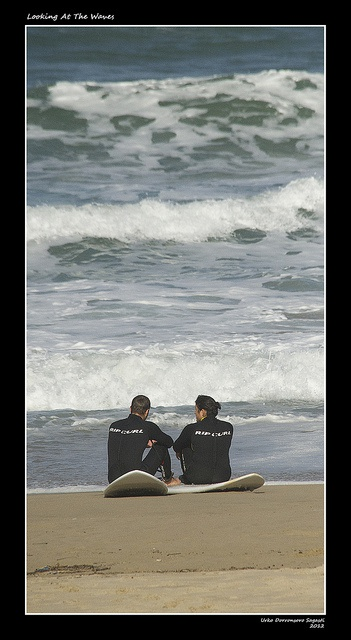Describe the objects in this image and their specific colors. I can see people in black, gray, and darkgray tones, people in black, gray, and darkgray tones, surfboard in black, gray, and darkgray tones, and surfboard in black, gray, and darkgray tones in this image. 